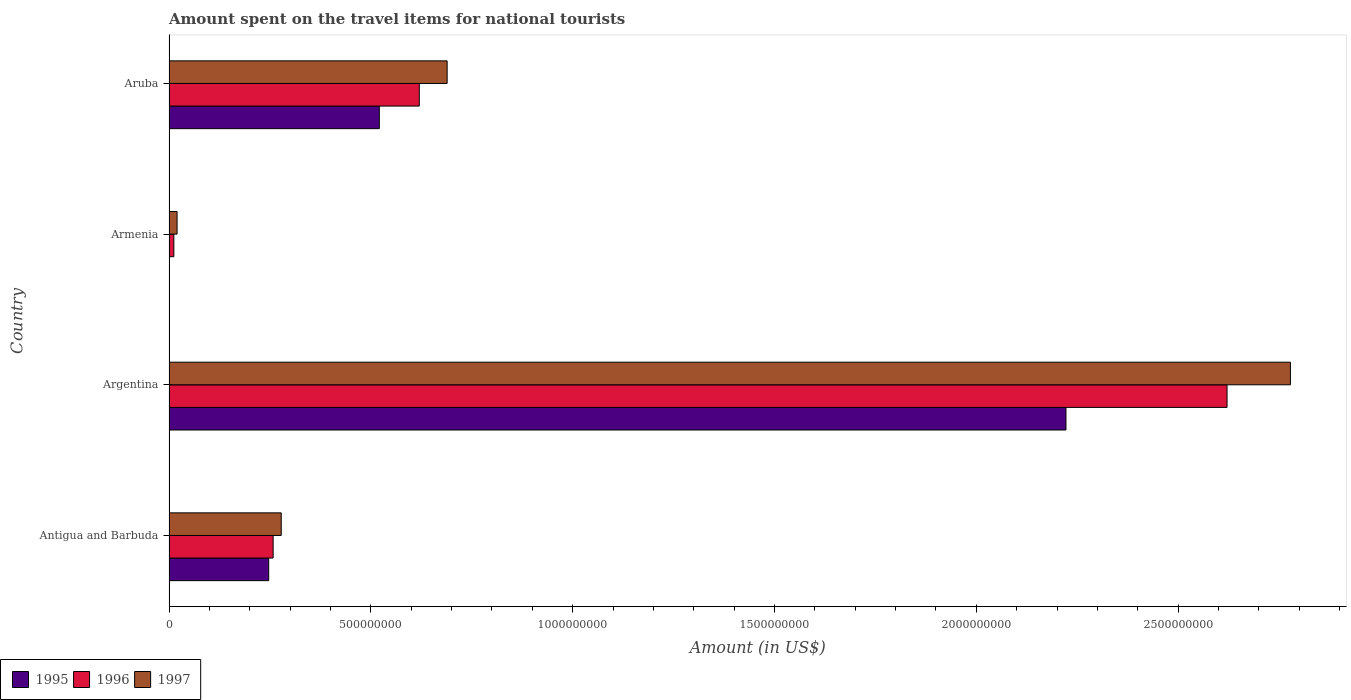How many different coloured bars are there?
Your answer should be compact. 3. Are the number of bars per tick equal to the number of legend labels?
Provide a succinct answer. Yes. How many bars are there on the 2nd tick from the top?
Your answer should be compact. 3. What is the label of the 1st group of bars from the top?
Your response must be concise. Aruba. In how many cases, is the number of bars for a given country not equal to the number of legend labels?
Your answer should be compact. 0. What is the amount spent on the travel items for national tourists in 1997 in Antigua and Barbuda?
Your answer should be very brief. 2.78e+08. Across all countries, what is the maximum amount spent on the travel items for national tourists in 1995?
Your answer should be compact. 2.22e+09. In which country was the amount spent on the travel items for national tourists in 1997 minimum?
Provide a short and direct response. Armenia. What is the total amount spent on the travel items for national tourists in 1996 in the graph?
Offer a terse response. 3.51e+09. What is the difference between the amount spent on the travel items for national tourists in 1997 in Antigua and Barbuda and that in Aruba?
Keep it short and to the point. -4.11e+08. What is the difference between the amount spent on the travel items for national tourists in 1995 in Argentina and the amount spent on the travel items for national tourists in 1996 in Armenia?
Your response must be concise. 2.21e+09. What is the average amount spent on the travel items for national tourists in 1997 per country?
Offer a terse response. 9.41e+08. What is the difference between the amount spent on the travel items for national tourists in 1996 and amount spent on the travel items for national tourists in 1995 in Argentina?
Your answer should be very brief. 3.99e+08. In how many countries, is the amount spent on the travel items for national tourists in 1995 greater than 600000000 US$?
Provide a short and direct response. 1. What is the ratio of the amount spent on the travel items for national tourists in 1995 in Armenia to that in Aruba?
Offer a very short reply. 0. Is the amount spent on the travel items for national tourists in 1996 in Armenia less than that in Aruba?
Offer a terse response. Yes. What is the difference between the highest and the second highest amount spent on the travel items for national tourists in 1995?
Offer a very short reply. 1.70e+09. What is the difference between the highest and the lowest amount spent on the travel items for national tourists in 1997?
Offer a terse response. 2.76e+09. In how many countries, is the amount spent on the travel items for national tourists in 1996 greater than the average amount spent on the travel items for national tourists in 1996 taken over all countries?
Your answer should be very brief. 1. What does the 1st bar from the top in Armenia represents?
Make the answer very short. 1997. What does the 1st bar from the bottom in Armenia represents?
Ensure brevity in your answer.  1995. Does the graph contain any zero values?
Offer a terse response. No. Does the graph contain grids?
Give a very brief answer. No. How many legend labels are there?
Your response must be concise. 3. How are the legend labels stacked?
Keep it short and to the point. Horizontal. What is the title of the graph?
Your answer should be very brief. Amount spent on the travel items for national tourists. Does "1987" appear as one of the legend labels in the graph?
Ensure brevity in your answer.  No. What is the label or title of the X-axis?
Offer a terse response. Amount (in US$). What is the Amount (in US$) of 1995 in Antigua and Barbuda?
Provide a succinct answer. 2.47e+08. What is the Amount (in US$) of 1996 in Antigua and Barbuda?
Keep it short and to the point. 2.58e+08. What is the Amount (in US$) of 1997 in Antigua and Barbuda?
Provide a short and direct response. 2.78e+08. What is the Amount (in US$) in 1995 in Argentina?
Your answer should be compact. 2.22e+09. What is the Amount (in US$) of 1996 in Argentina?
Keep it short and to the point. 2.62e+09. What is the Amount (in US$) in 1997 in Argentina?
Your response must be concise. 2.78e+09. What is the Amount (in US$) in 1997 in Armenia?
Your answer should be very brief. 2.00e+07. What is the Amount (in US$) in 1995 in Aruba?
Offer a very short reply. 5.21e+08. What is the Amount (in US$) of 1996 in Aruba?
Give a very brief answer. 6.20e+08. What is the Amount (in US$) of 1997 in Aruba?
Your response must be concise. 6.89e+08. Across all countries, what is the maximum Amount (in US$) in 1995?
Your answer should be very brief. 2.22e+09. Across all countries, what is the maximum Amount (in US$) in 1996?
Provide a short and direct response. 2.62e+09. Across all countries, what is the maximum Amount (in US$) of 1997?
Provide a succinct answer. 2.78e+09. Across all countries, what is the minimum Amount (in US$) of 1995?
Your response must be concise. 1.00e+06. What is the total Amount (in US$) in 1995 in the graph?
Offer a terse response. 2.99e+09. What is the total Amount (in US$) in 1996 in the graph?
Offer a terse response. 3.51e+09. What is the total Amount (in US$) in 1997 in the graph?
Offer a very short reply. 3.76e+09. What is the difference between the Amount (in US$) in 1995 in Antigua and Barbuda and that in Argentina?
Provide a short and direct response. -1.98e+09. What is the difference between the Amount (in US$) of 1996 in Antigua and Barbuda and that in Argentina?
Your response must be concise. -2.36e+09. What is the difference between the Amount (in US$) of 1997 in Antigua and Barbuda and that in Argentina?
Your answer should be very brief. -2.50e+09. What is the difference between the Amount (in US$) in 1995 in Antigua and Barbuda and that in Armenia?
Offer a very short reply. 2.46e+08. What is the difference between the Amount (in US$) of 1996 in Antigua and Barbuda and that in Armenia?
Your answer should be compact. 2.46e+08. What is the difference between the Amount (in US$) in 1997 in Antigua and Barbuda and that in Armenia?
Your answer should be very brief. 2.58e+08. What is the difference between the Amount (in US$) in 1995 in Antigua and Barbuda and that in Aruba?
Make the answer very short. -2.74e+08. What is the difference between the Amount (in US$) in 1996 in Antigua and Barbuda and that in Aruba?
Your answer should be very brief. -3.62e+08. What is the difference between the Amount (in US$) of 1997 in Antigua and Barbuda and that in Aruba?
Provide a short and direct response. -4.11e+08. What is the difference between the Amount (in US$) in 1995 in Argentina and that in Armenia?
Your response must be concise. 2.22e+09. What is the difference between the Amount (in US$) of 1996 in Argentina and that in Armenia?
Provide a succinct answer. 2.61e+09. What is the difference between the Amount (in US$) of 1997 in Argentina and that in Armenia?
Provide a short and direct response. 2.76e+09. What is the difference between the Amount (in US$) of 1995 in Argentina and that in Aruba?
Provide a succinct answer. 1.70e+09. What is the difference between the Amount (in US$) in 1996 in Argentina and that in Aruba?
Provide a short and direct response. 2.00e+09. What is the difference between the Amount (in US$) in 1997 in Argentina and that in Aruba?
Give a very brief answer. 2.09e+09. What is the difference between the Amount (in US$) in 1995 in Armenia and that in Aruba?
Ensure brevity in your answer.  -5.20e+08. What is the difference between the Amount (in US$) of 1996 in Armenia and that in Aruba?
Your response must be concise. -6.08e+08. What is the difference between the Amount (in US$) of 1997 in Armenia and that in Aruba?
Your answer should be very brief. -6.69e+08. What is the difference between the Amount (in US$) of 1995 in Antigua and Barbuda and the Amount (in US$) of 1996 in Argentina?
Your answer should be very brief. -2.37e+09. What is the difference between the Amount (in US$) in 1995 in Antigua and Barbuda and the Amount (in US$) in 1997 in Argentina?
Ensure brevity in your answer.  -2.53e+09. What is the difference between the Amount (in US$) of 1996 in Antigua and Barbuda and the Amount (in US$) of 1997 in Argentina?
Make the answer very short. -2.52e+09. What is the difference between the Amount (in US$) of 1995 in Antigua and Barbuda and the Amount (in US$) of 1996 in Armenia?
Ensure brevity in your answer.  2.35e+08. What is the difference between the Amount (in US$) in 1995 in Antigua and Barbuda and the Amount (in US$) in 1997 in Armenia?
Provide a succinct answer. 2.27e+08. What is the difference between the Amount (in US$) in 1996 in Antigua and Barbuda and the Amount (in US$) in 1997 in Armenia?
Provide a short and direct response. 2.38e+08. What is the difference between the Amount (in US$) in 1995 in Antigua and Barbuda and the Amount (in US$) in 1996 in Aruba?
Give a very brief answer. -3.73e+08. What is the difference between the Amount (in US$) of 1995 in Antigua and Barbuda and the Amount (in US$) of 1997 in Aruba?
Your response must be concise. -4.42e+08. What is the difference between the Amount (in US$) of 1996 in Antigua and Barbuda and the Amount (in US$) of 1997 in Aruba?
Offer a very short reply. -4.31e+08. What is the difference between the Amount (in US$) of 1995 in Argentina and the Amount (in US$) of 1996 in Armenia?
Ensure brevity in your answer.  2.21e+09. What is the difference between the Amount (in US$) of 1995 in Argentina and the Amount (in US$) of 1997 in Armenia?
Offer a terse response. 2.20e+09. What is the difference between the Amount (in US$) of 1996 in Argentina and the Amount (in US$) of 1997 in Armenia?
Provide a succinct answer. 2.60e+09. What is the difference between the Amount (in US$) in 1995 in Argentina and the Amount (in US$) in 1996 in Aruba?
Your answer should be very brief. 1.60e+09. What is the difference between the Amount (in US$) of 1995 in Argentina and the Amount (in US$) of 1997 in Aruba?
Your response must be concise. 1.53e+09. What is the difference between the Amount (in US$) of 1996 in Argentina and the Amount (in US$) of 1997 in Aruba?
Your response must be concise. 1.93e+09. What is the difference between the Amount (in US$) of 1995 in Armenia and the Amount (in US$) of 1996 in Aruba?
Make the answer very short. -6.19e+08. What is the difference between the Amount (in US$) of 1995 in Armenia and the Amount (in US$) of 1997 in Aruba?
Give a very brief answer. -6.88e+08. What is the difference between the Amount (in US$) in 1996 in Armenia and the Amount (in US$) in 1997 in Aruba?
Provide a short and direct response. -6.77e+08. What is the average Amount (in US$) in 1995 per country?
Your answer should be very brief. 7.48e+08. What is the average Amount (in US$) of 1996 per country?
Provide a short and direct response. 8.78e+08. What is the average Amount (in US$) in 1997 per country?
Your answer should be very brief. 9.41e+08. What is the difference between the Amount (in US$) of 1995 and Amount (in US$) of 1996 in Antigua and Barbuda?
Provide a succinct answer. -1.10e+07. What is the difference between the Amount (in US$) of 1995 and Amount (in US$) of 1997 in Antigua and Barbuda?
Provide a succinct answer. -3.10e+07. What is the difference between the Amount (in US$) in 1996 and Amount (in US$) in 1997 in Antigua and Barbuda?
Your answer should be compact. -2.00e+07. What is the difference between the Amount (in US$) of 1995 and Amount (in US$) of 1996 in Argentina?
Offer a very short reply. -3.99e+08. What is the difference between the Amount (in US$) in 1995 and Amount (in US$) in 1997 in Argentina?
Your answer should be compact. -5.56e+08. What is the difference between the Amount (in US$) of 1996 and Amount (in US$) of 1997 in Argentina?
Offer a very short reply. -1.57e+08. What is the difference between the Amount (in US$) of 1995 and Amount (in US$) of 1996 in Armenia?
Ensure brevity in your answer.  -1.10e+07. What is the difference between the Amount (in US$) of 1995 and Amount (in US$) of 1997 in Armenia?
Your response must be concise. -1.90e+07. What is the difference between the Amount (in US$) in 1996 and Amount (in US$) in 1997 in Armenia?
Your answer should be very brief. -8.00e+06. What is the difference between the Amount (in US$) of 1995 and Amount (in US$) of 1996 in Aruba?
Make the answer very short. -9.90e+07. What is the difference between the Amount (in US$) in 1995 and Amount (in US$) in 1997 in Aruba?
Your answer should be compact. -1.68e+08. What is the difference between the Amount (in US$) of 1996 and Amount (in US$) of 1997 in Aruba?
Offer a very short reply. -6.90e+07. What is the ratio of the Amount (in US$) in 1995 in Antigua and Barbuda to that in Argentina?
Provide a succinct answer. 0.11. What is the ratio of the Amount (in US$) of 1996 in Antigua and Barbuda to that in Argentina?
Keep it short and to the point. 0.1. What is the ratio of the Amount (in US$) in 1997 in Antigua and Barbuda to that in Argentina?
Give a very brief answer. 0.1. What is the ratio of the Amount (in US$) of 1995 in Antigua and Barbuda to that in Armenia?
Your response must be concise. 247. What is the ratio of the Amount (in US$) of 1997 in Antigua and Barbuda to that in Armenia?
Make the answer very short. 13.9. What is the ratio of the Amount (in US$) in 1995 in Antigua and Barbuda to that in Aruba?
Keep it short and to the point. 0.47. What is the ratio of the Amount (in US$) in 1996 in Antigua and Barbuda to that in Aruba?
Make the answer very short. 0.42. What is the ratio of the Amount (in US$) in 1997 in Antigua and Barbuda to that in Aruba?
Provide a succinct answer. 0.4. What is the ratio of the Amount (in US$) of 1995 in Argentina to that in Armenia?
Your answer should be very brief. 2222. What is the ratio of the Amount (in US$) in 1996 in Argentina to that in Armenia?
Offer a very short reply. 218.42. What is the ratio of the Amount (in US$) of 1997 in Argentina to that in Armenia?
Offer a very short reply. 138.9. What is the ratio of the Amount (in US$) in 1995 in Argentina to that in Aruba?
Your answer should be compact. 4.26. What is the ratio of the Amount (in US$) of 1996 in Argentina to that in Aruba?
Ensure brevity in your answer.  4.23. What is the ratio of the Amount (in US$) of 1997 in Argentina to that in Aruba?
Make the answer very short. 4.03. What is the ratio of the Amount (in US$) in 1995 in Armenia to that in Aruba?
Give a very brief answer. 0. What is the ratio of the Amount (in US$) of 1996 in Armenia to that in Aruba?
Provide a succinct answer. 0.02. What is the ratio of the Amount (in US$) in 1997 in Armenia to that in Aruba?
Provide a succinct answer. 0.03. What is the difference between the highest and the second highest Amount (in US$) in 1995?
Provide a succinct answer. 1.70e+09. What is the difference between the highest and the second highest Amount (in US$) in 1996?
Your answer should be compact. 2.00e+09. What is the difference between the highest and the second highest Amount (in US$) of 1997?
Your response must be concise. 2.09e+09. What is the difference between the highest and the lowest Amount (in US$) of 1995?
Your response must be concise. 2.22e+09. What is the difference between the highest and the lowest Amount (in US$) of 1996?
Keep it short and to the point. 2.61e+09. What is the difference between the highest and the lowest Amount (in US$) in 1997?
Your answer should be compact. 2.76e+09. 